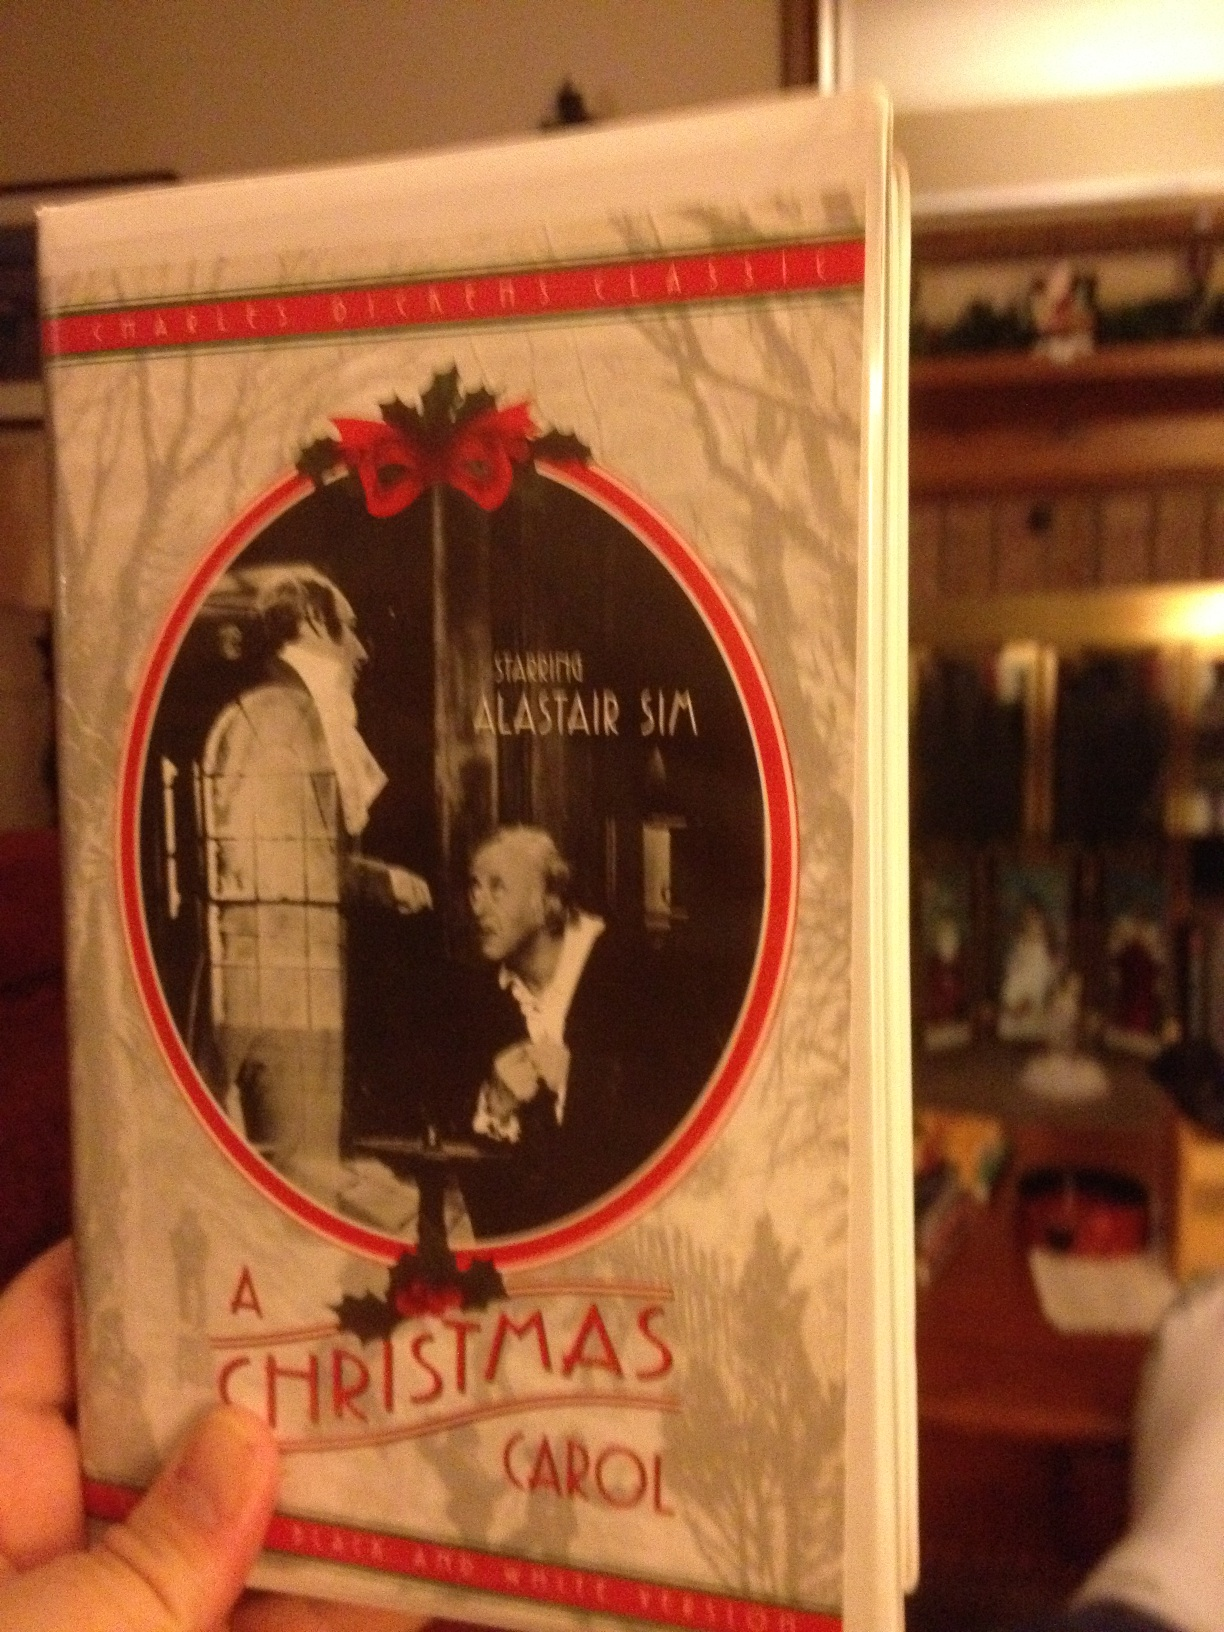Imagine if Scrooge had a pet cat that also experienced the visits from the spirits. Describe how this would change the story. If Scrooge had a pet cat that experienced the visits from the spirits, it would add a unique and whimsical twist to the story. The cat, perhaps named 'Whiskers,' would serve as an additional companion to Scrooge throughout his ghostly encounters. Whiskers might react curiously or fearfully to the apparitions, adding some lighthearted moments to the otherwise intense and transformative journey. Additionally, the cat's presence could highlight Scrooge's initial neglect and eventual care for even the smallest and most silent lives around him, symbolizing his growth in compassion and empathy. The playful interactions between Scrooge and Whiskers could serve as a subtle yet touching backdrop to Scrooge's redemption arc. 